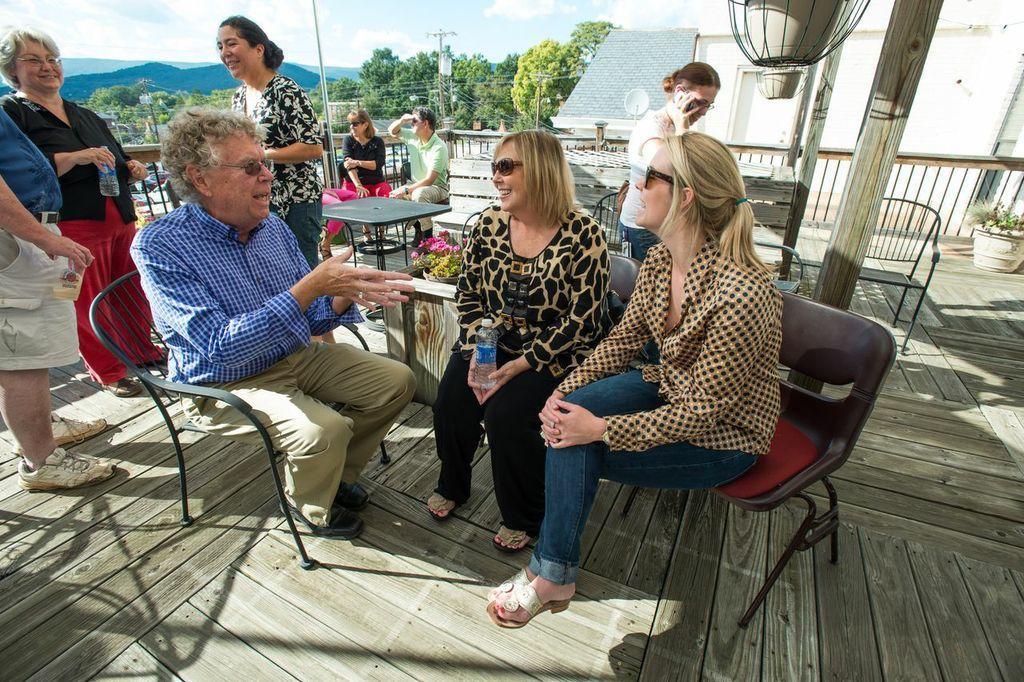Describe this image in one or two sentences. This image is taken outdoors. At the bottom of the image there is a wooden platform. At the top of the image there is the sky with clouds. In the background there are a few hills and there are many trees. There are a few poles with wires. On the right side of the image there is a house. There is a plant in the pot. There is an empty chair and there is a railing. In the middle of the image a man and two women are sitting on the chairs and talking and a few are standing on the wooden platform and a few people are sitting on the chairs. There is a table. 